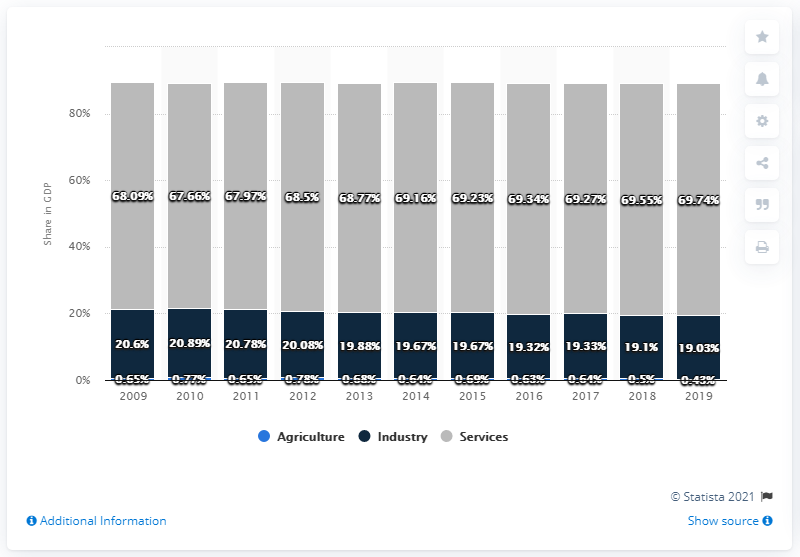Outline some significant characteristics in this image. The most productive economic sector in the area is services. According to data from 2019, agriculture represented 0.43% of Belgium's total Gross Domestic Product. The difference between the highest and smallest service in the area is 2.08. 